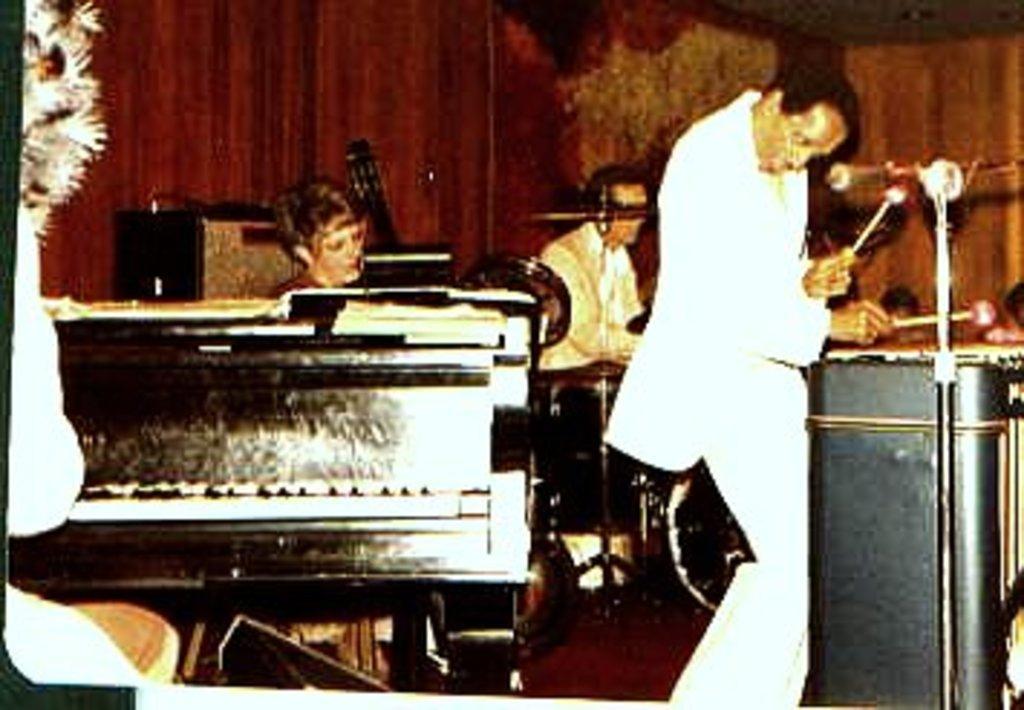In one or two sentences, can you explain what this image depicts? In a room there are so many musical instruments and people playing music in it. 